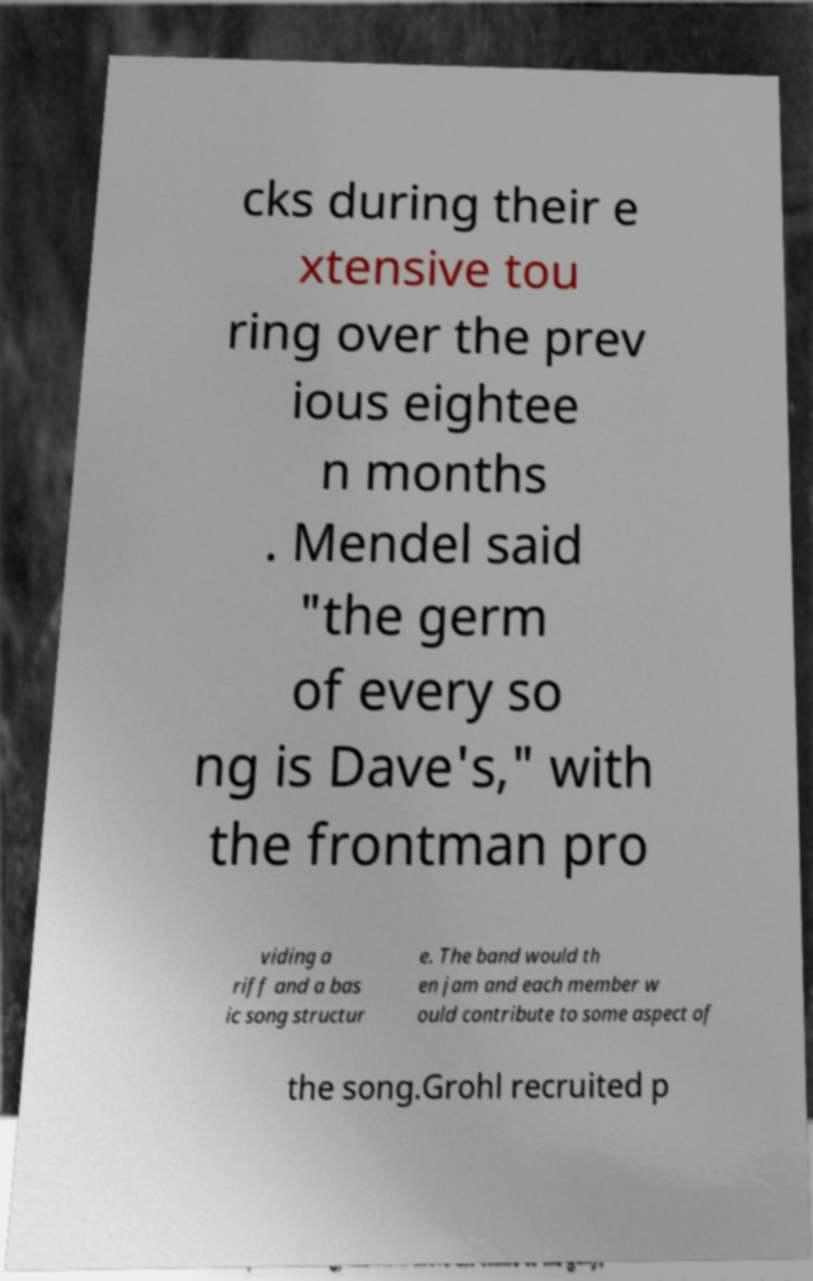Could you assist in decoding the text presented in this image and type it out clearly? cks during their e xtensive tou ring over the prev ious eightee n months . Mendel said "the germ of every so ng is Dave's," with the frontman pro viding a riff and a bas ic song structur e. The band would th en jam and each member w ould contribute to some aspect of the song.Grohl recruited p 